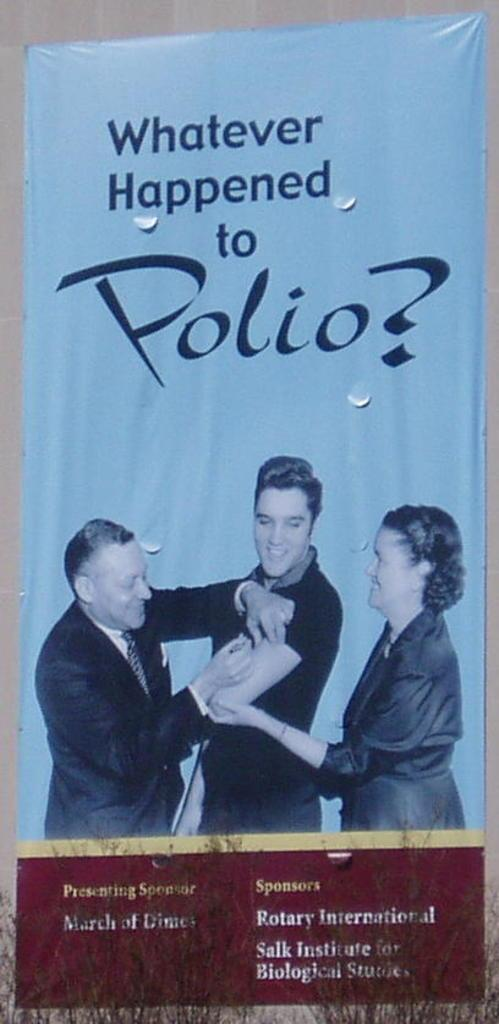<image>
Relay a brief, clear account of the picture shown. A poster of Elvis Presley getting a Polio Vaccine. 